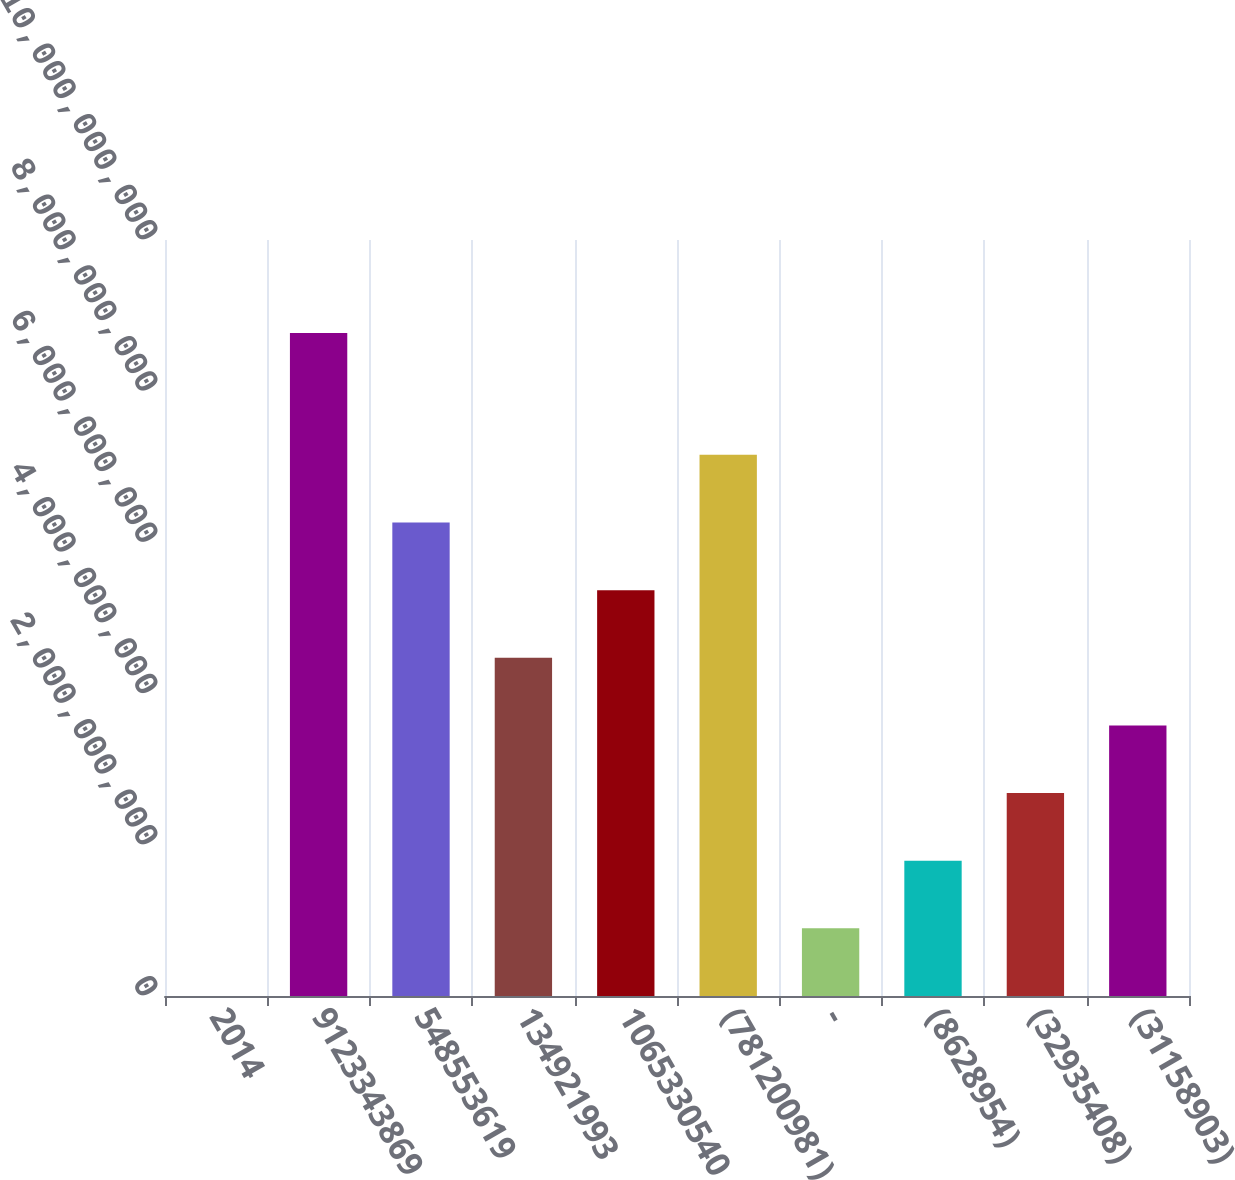Convert chart to OTSL. <chart><loc_0><loc_0><loc_500><loc_500><bar_chart><fcel>2014<fcel>9123343869<fcel>548553619<fcel>134921993<fcel>1065330540<fcel>(781200981)<fcel>-<fcel>(8628954)<fcel>(32935408)<fcel>(31158903)<nl><fcel>2012<fcel>8.77126e+09<fcel>6.2631e+09<fcel>4.47364e+09<fcel>5.36837e+09<fcel>7.15783e+09<fcel>8.9473e+08<fcel>1.78946e+09<fcel>2.68419e+09<fcel>3.57892e+09<nl></chart> 